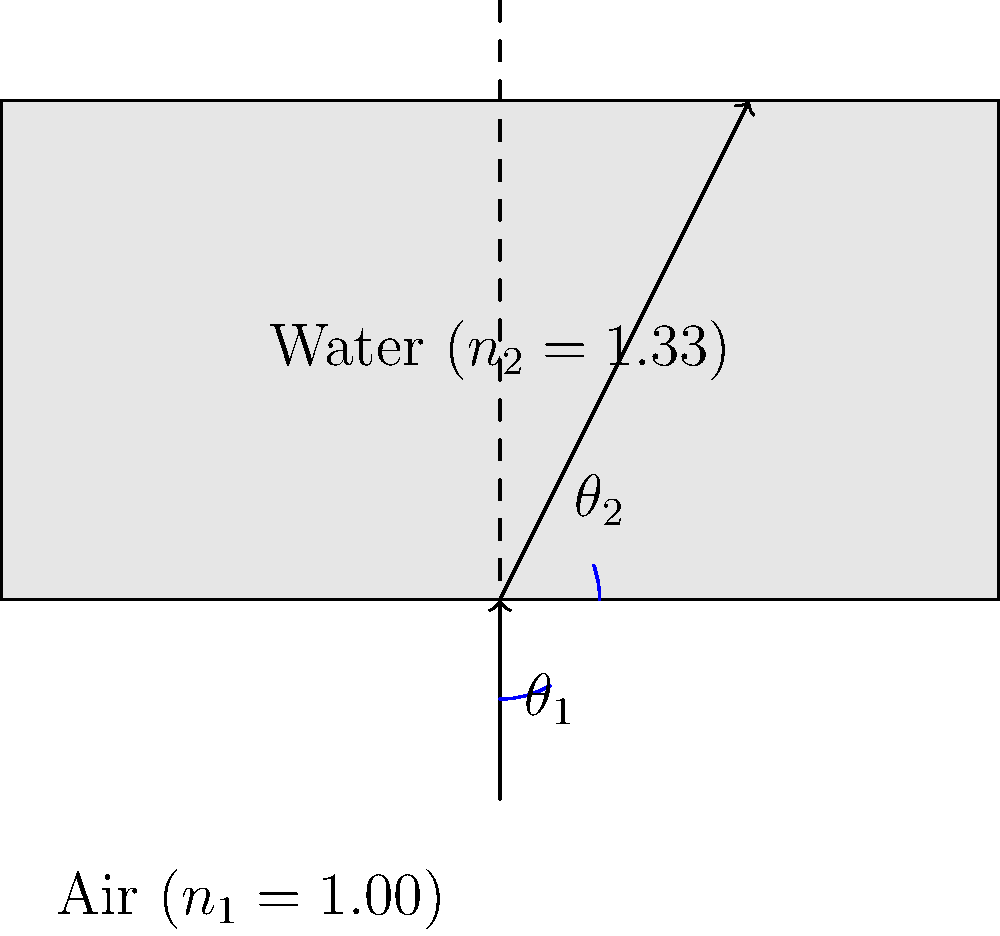As a technology specialist developing online platforms for virtual social work training, you're creating an interactive module on the physics of light to demonstrate how different mediums affect communication tools. Using the ray diagram provided, calculate the angle of refraction ($\theta_2$) when light passes from air into water at an incident angle ($\theta_1$) of 30°. Use Snell's law and the refractive indices given in the diagram. To solve this problem, we'll use Snell's law and follow these steps:

1) Recall Snell's law: $n_1 \sin(\theta_1) = n_2 \sin(\theta_2)$

2) We're given:
   - $n_1 = 1.00$ (air)
   - $n_2 = 1.33$ (water)
   - $\theta_1 = 30°$

3) Substitute these values into Snell's law:
   $1.00 \sin(30°) = 1.33 \sin(\theta_2)$

4) Simplify the left side:
   $0.5 = 1.33 \sin(\theta_2)$

5) Solve for $\sin(\theta_2)$:
   $\sin(\theta_2) = \frac{0.5}{1.33} \approx 0.3759$

6) Take the inverse sine (arcsin) of both sides:
   $\theta_2 = \arcsin(0.3759)$

7) Calculate the final result:
   $\theta_2 \approx 22.1°$

This result shows how light bends towards the normal when entering a denser medium, which is crucial for understanding how light behaves in different materials used in communication technologies.
Answer: $22.1°$ 